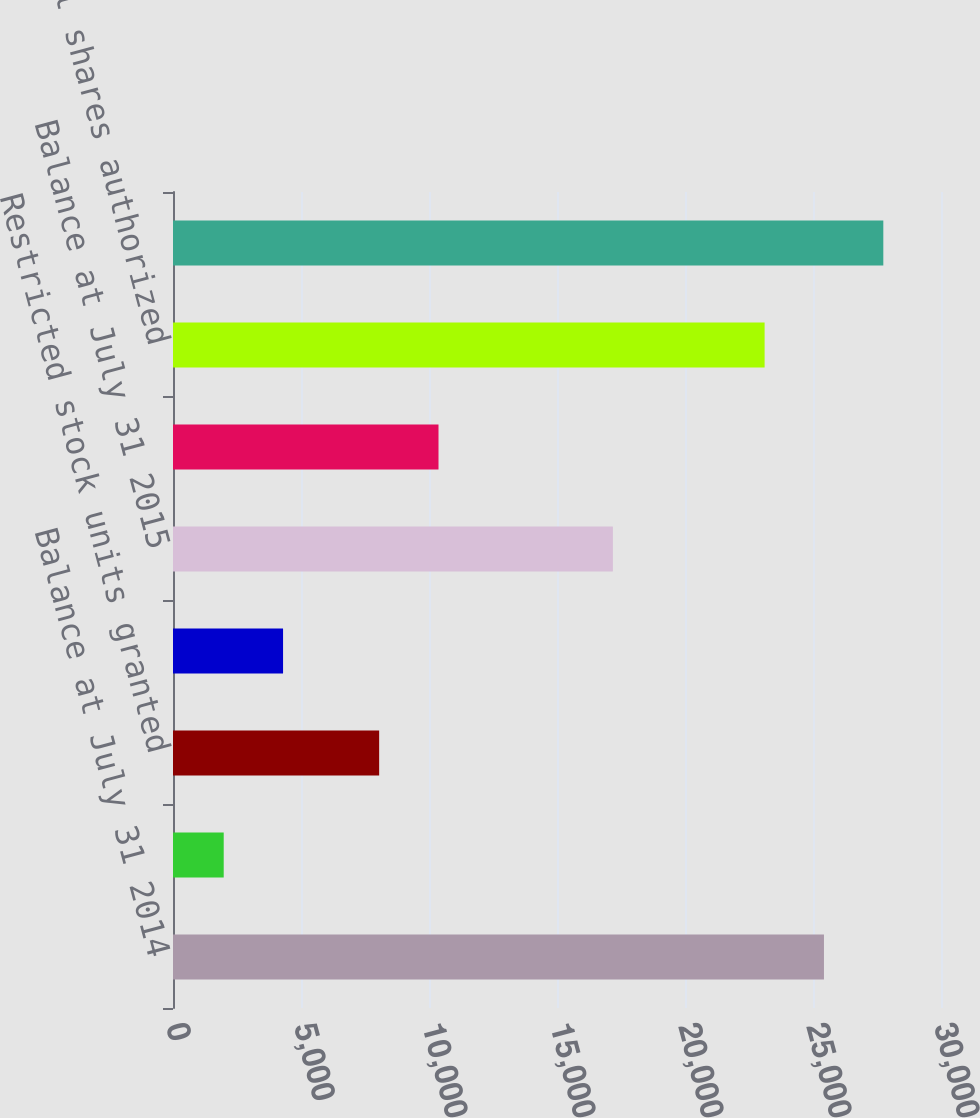<chart> <loc_0><loc_0><loc_500><loc_500><bar_chart><fcel>Balance at July 31 2014<fcel>Options granted<fcel>Restricted stock units granted<fcel>Share-based awards<fcel>Balance at July 31 2015<fcel>Balance at July 31 2016<fcel>Additional shares authorized<fcel>Balance at July 31 2017<nl><fcel>25428.3<fcel>1981<fcel>8053<fcel>4299.3<fcel>17183<fcel>10371.3<fcel>23110<fcel>27746.6<nl></chart> 